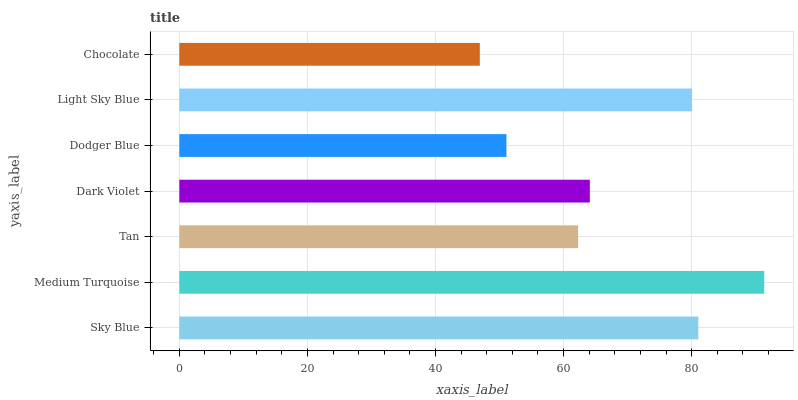Is Chocolate the minimum?
Answer yes or no. Yes. Is Medium Turquoise the maximum?
Answer yes or no. Yes. Is Tan the minimum?
Answer yes or no. No. Is Tan the maximum?
Answer yes or no. No. Is Medium Turquoise greater than Tan?
Answer yes or no. Yes. Is Tan less than Medium Turquoise?
Answer yes or no. Yes. Is Tan greater than Medium Turquoise?
Answer yes or no. No. Is Medium Turquoise less than Tan?
Answer yes or no. No. Is Dark Violet the high median?
Answer yes or no. Yes. Is Dark Violet the low median?
Answer yes or no. Yes. Is Sky Blue the high median?
Answer yes or no. No. Is Medium Turquoise the low median?
Answer yes or no. No. 